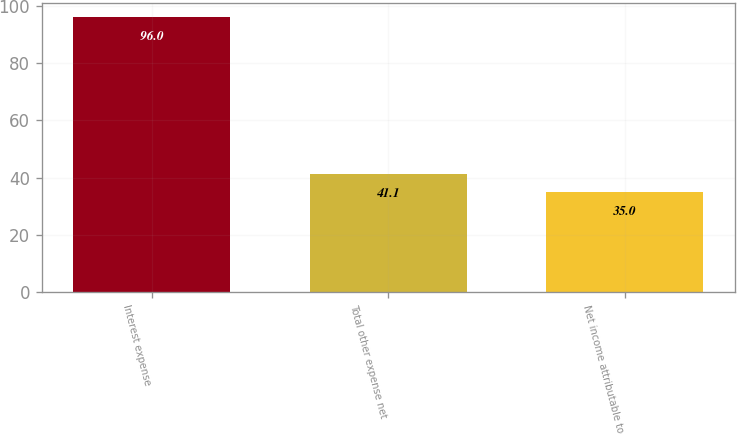Convert chart to OTSL. <chart><loc_0><loc_0><loc_500><loc_500><bar_chart><fcel>Interest expense<fcel>Total other expense net<fcel>Net income attributable to<nl><fcel>96<fcel>41.1<fcel>35<nl></chart> 